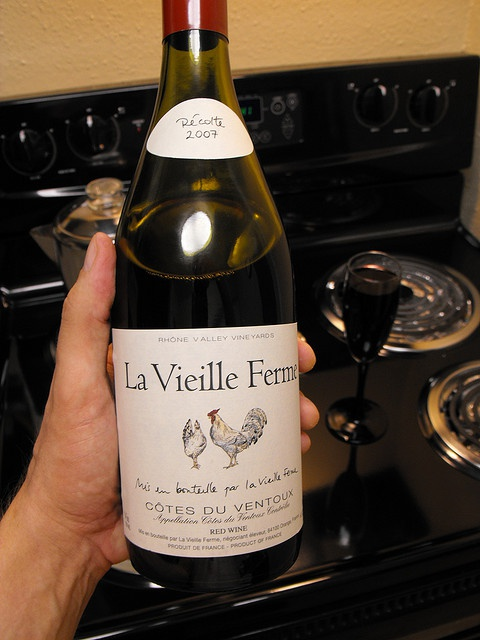Describe the objects in this image and their specific colors. I can see bottle in tan, black, and lightgray tones, oven in tan, black, maroon, and gray tones, people in tan, salmon, brown, and maroon tones, wine glass in tan, black, maroon, and gray tones, and bird in tan and darkgray tones in this image. 